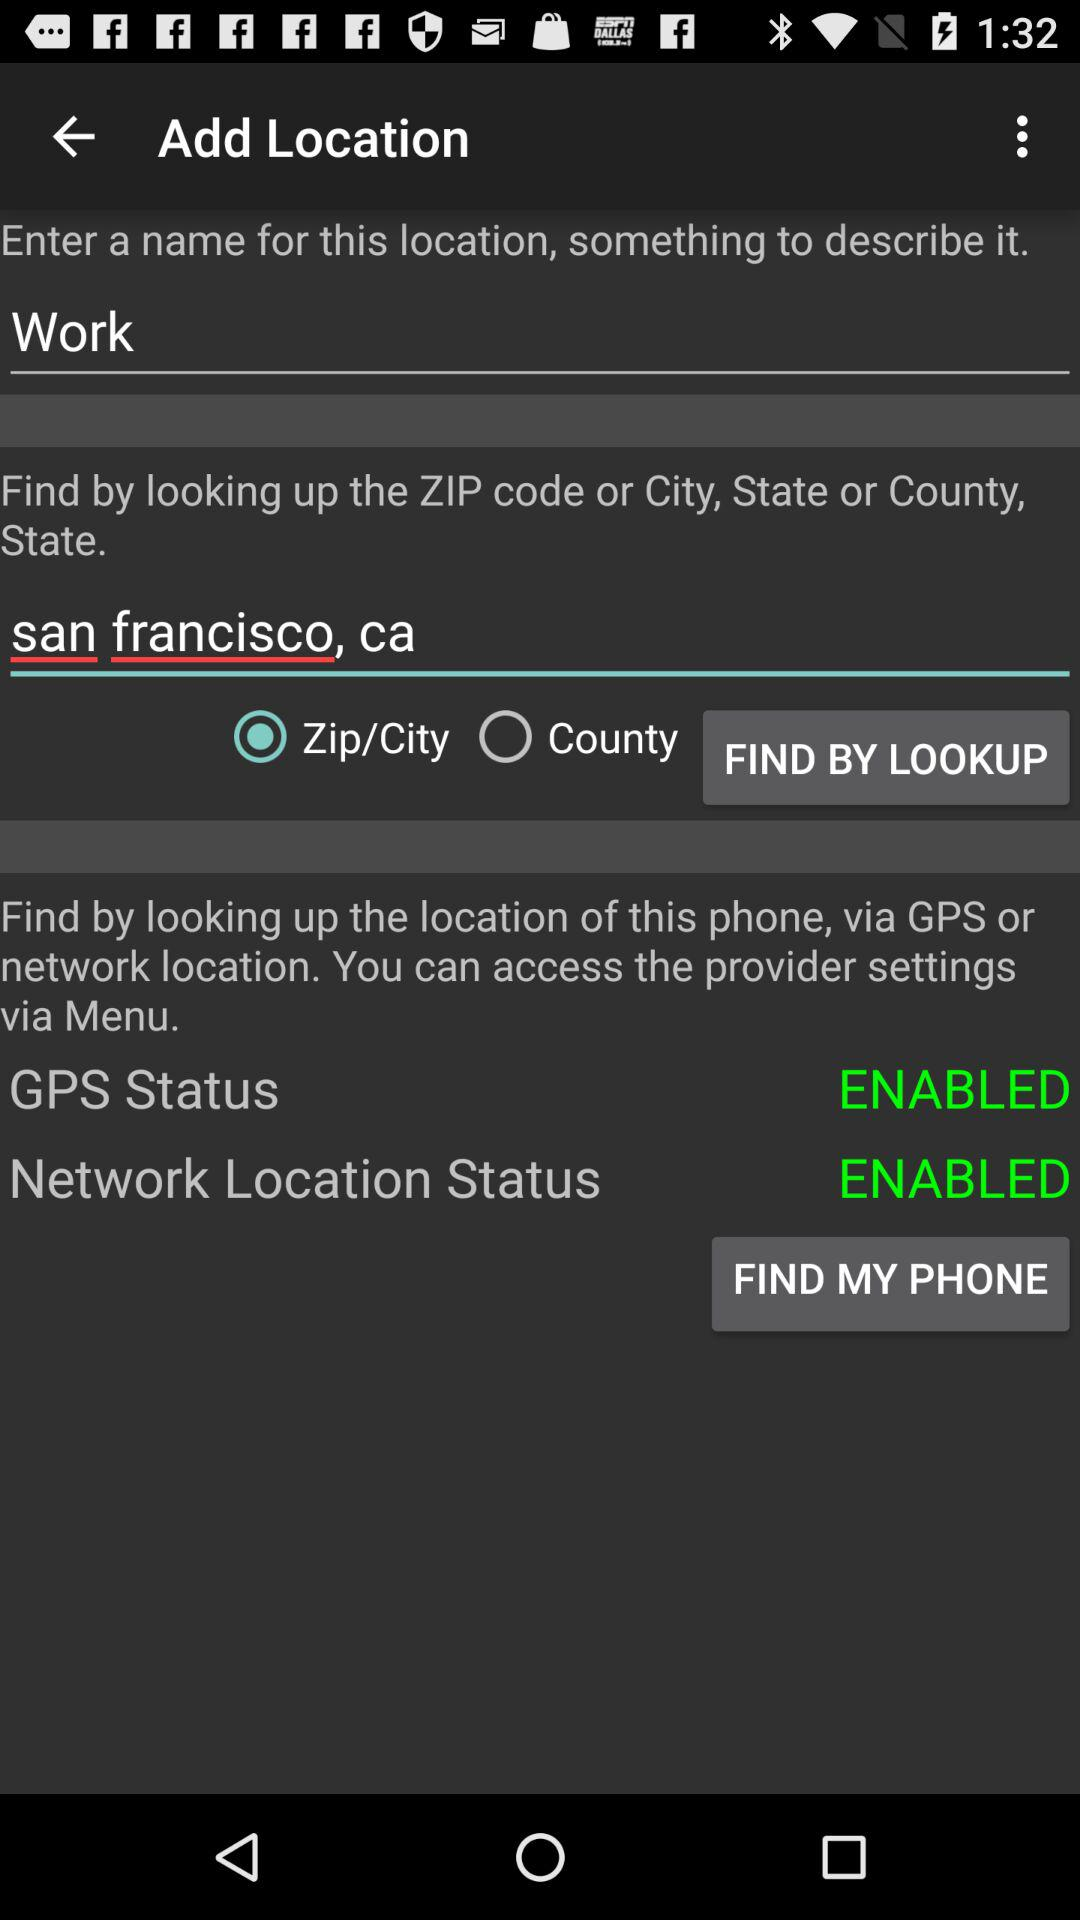Which option has been selected from find my phone?
When the provided information is insufficient, respond with <no answer>. <no answer> 